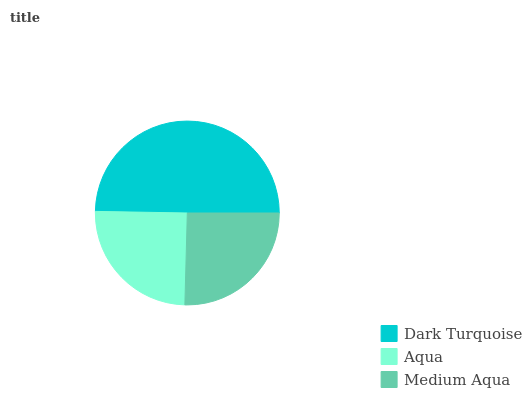Is Aqua the minimum?
Answer yes or no. Yes. Is Dark Turquoise the maximum?
Answer yes or no. Yes. Is Medium Aqua the minimum?
Answer yes or no. No. Is Medium Aqua the maximum?
Answer yes or no. No. Is Medium Aqua greater than Aqua?
Answer yes or no. Yes. Is Aqua less than Medium Aqua?
Answer yes or no. Yes. Is Aqua greater than Medium Aqua?
Answer yes or no. No. Is Medium Aqua less than Aqua?
Answer yes or no. No. Is Medium Aqua the high median?
Answer yes or no. Yes. Is Medium Aqua the low median?
Answer yes or no. Yes. Is Dark Turquoise the high median?
Answer yes or no. No. Is Dark Turquoise the low median?
Answer yes or no. No. 